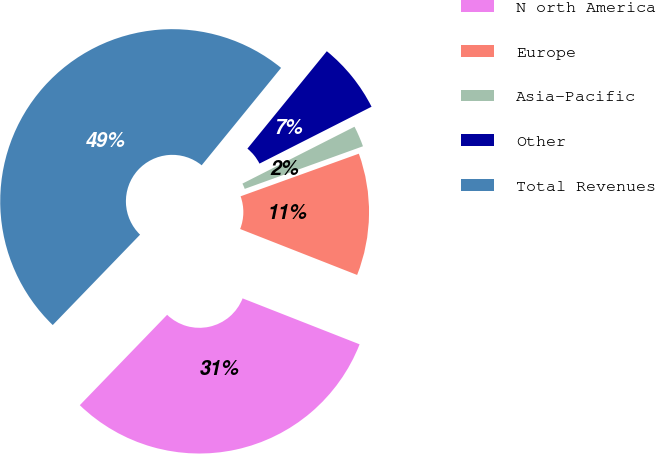Convert chart. <chart><loc_0><loc_0><loc_500><loc_500><pie_chart><fcel>N orth America<fcel>Europe<fcel>Asia-Pacific<fcel>Other<fcel>Total Revenues<nl><fcel>31.27%<fcel>11.46%<fcel>1.97%<fcel>6.64%<fcel>48.66%<nl></chart> 